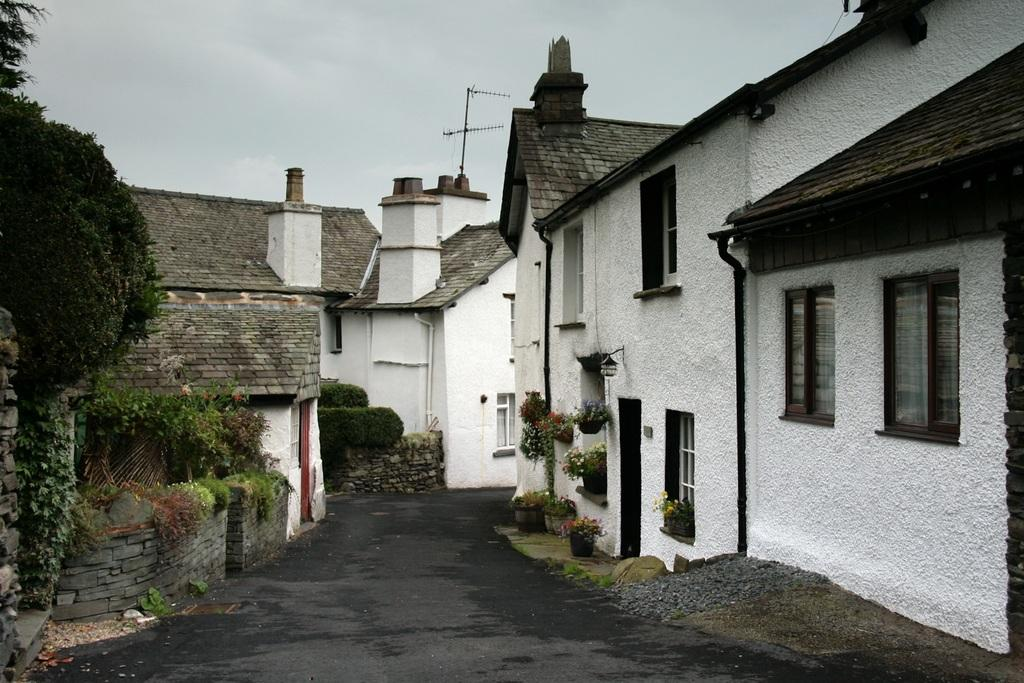What type of structures are visible in the image? There is a group of houses in the image. What features can be seen on the houses? The houses have roofs and windows. What type of vegetation is present in the image? There are plants with flowers and trees visible in the image. What type of surface can be seen in the image? There is a pathway in the image. What is attached to the houses? There is an antenna in the image. What is the condition of the sky in the image? The sky is visible in the image and appears cloudy. What type of voyage is being planned by the people in the image? There are no people visible in the image, and therefore no voyage can be planned. What type of observation is being made by the person with the telescope in the image? There is no telescope or person making an observation present in the image. 